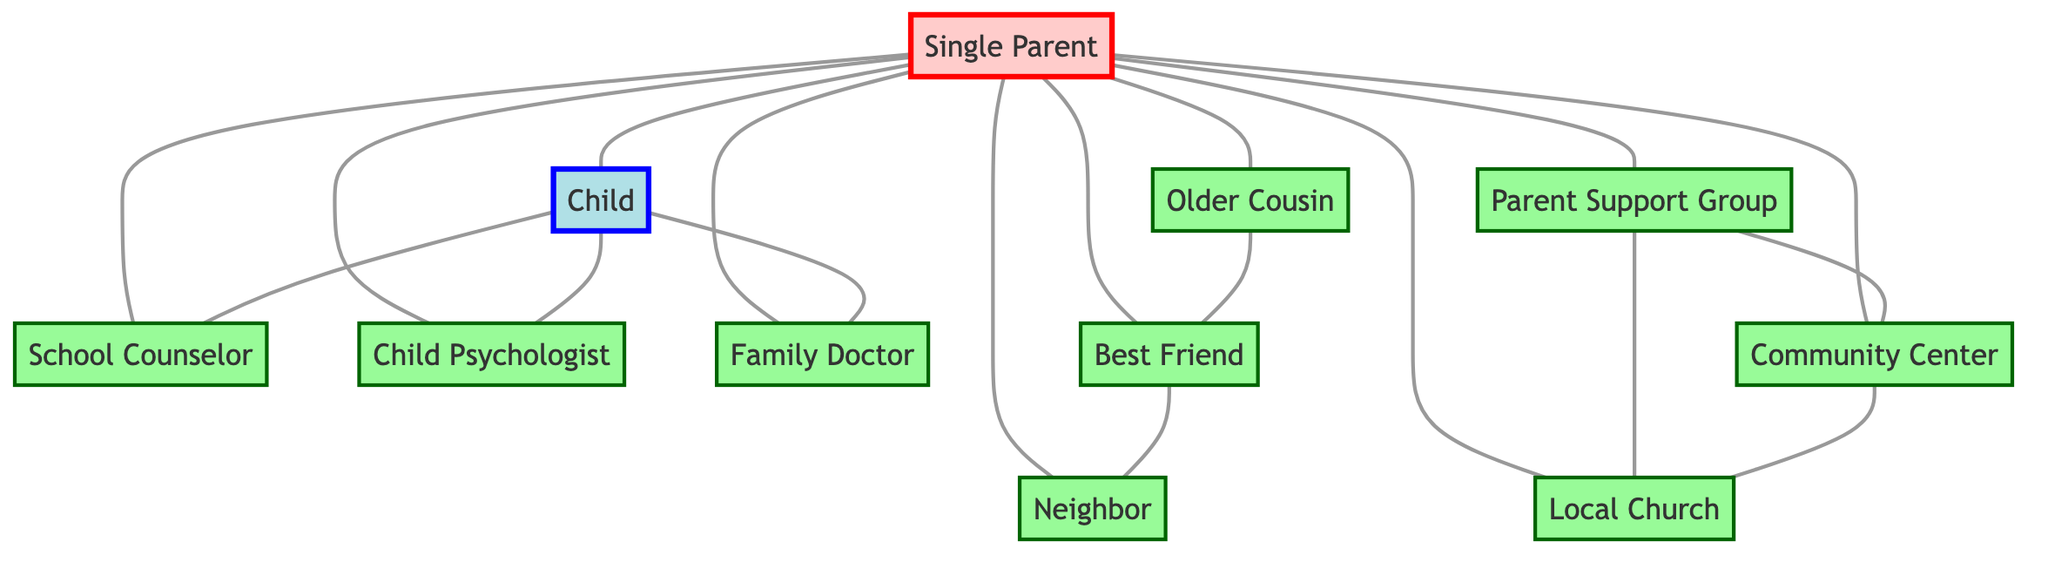What is the total number of nodes in the diagram? The diagram contains ten nodes: Single Parent, Child, Older Cousin, Parent Support Group, School Counselor, Child Psychologist, Family Doctor, Community Center, Local Church, Best Friend, and Neighbor. Counting them gives a total of eleven nodes.
Answer: eleven Which resource is directly connected to both the Single Parent and the Child? The School Counselor is the only resource that connects both the Single Parent and the Child in the diagram. This can be observed by following the edges that directly link the Single Parent to the School Counselor and the Child to the School Counselor.
Answer: School Counselor How many edges connect the Single Parent to other nodes? The Single Parent is connected to ten other nodes, including the Child, Older Cousin, Parent Support Group, School Counselor, Child Psychologist, Family Doctor, Community Center, Local Church, Best Friend, and Neighbor. Counting these edges leads to a total of ten connections.
Answer: ten Which two nodes are indirectly connected through the Older Cousin? The Best Friend and the Older Cousin are directly connected to each other, establishing an indirect connection to the Single Parent. To find this, we look at the edges and see that the Older Cousin connects to the Best Friend directly and to the Single Parent indirectly.
Answer: Best Friend What is a common link between the Parent Support Group and the Community Center? The Parent Support Group and the Community Center are directly connected by an edge in the diagram. They share a direct connection, indicating a support relationship.
Answer: Community Center How many connections does the Best Friend have? The Best Friend is connected to two nodes: the Older Cousin and the Neighbor. By examining the edges from the Best Friend node, we can find these two direct connections.
Answer: two Which node has no direct connection to the Family Doctor? The Older Cousin has no direct connection to the Family Doctor based on examining the edges connected to each node. There is no edge connecting these two nodes directly in the diagram.
Answer: Older Cousin How many support resources are directly connected to the Single Parent? The Single Parent is directly connected to ten support resources: Older Cousin, Parent Support Group, School Counselor, Child Psychologist, Family Doctor, Community Center, Local Church, Best Friend, Neighbor, and Child. Counting all of these demonstrates that there are ten direct connections.
Answer: ten What type of node is the Child in the diagram? The Child is represented as a 'Child' node, which is designated with a specific color (blue). This indicates its unique role compared to other nodes.
Answer: Child 